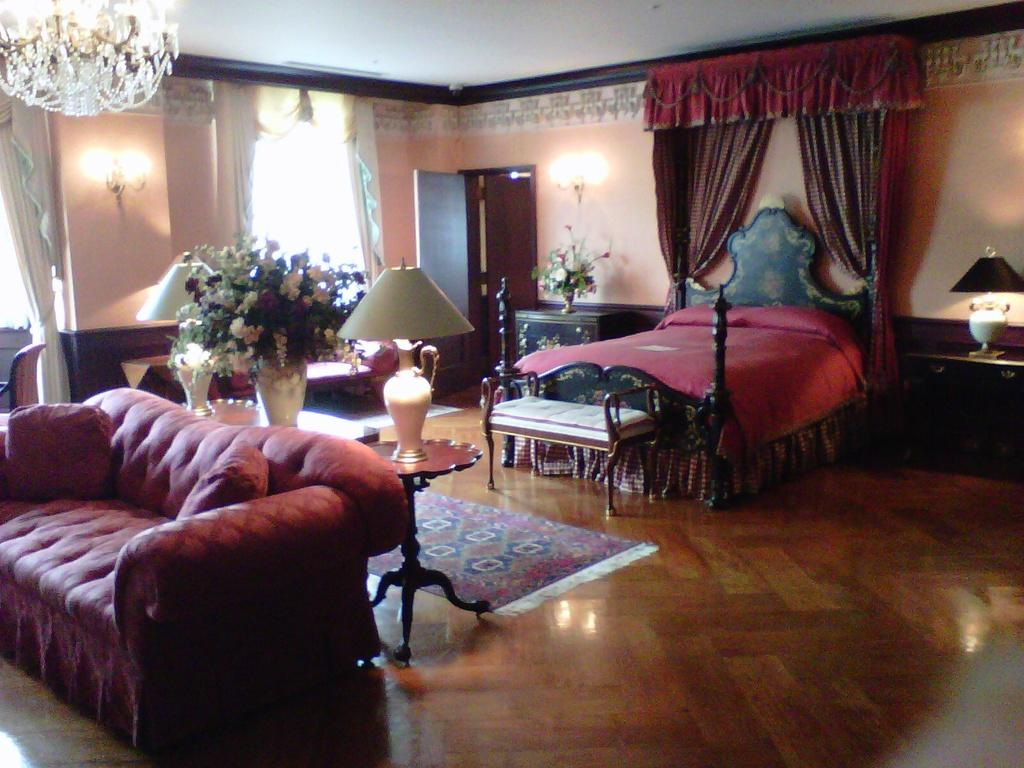What type of furniture is present in the image? There is a sofa and a bed in the image. Where is the bed located in the room? The bed is at the back of the room. What type of lighting is present in the image? There is a table lamp in the image. Where is the table lamp placed in relation to the sofa and bed? The table lamp is between the sofa and the bed. What can be found on the floor in the image? There is a door mat on the floor in the image. What type of oatmeal is being served on the bed in the image? There is no oatmeal present in the image; it features a sofa, a bed, a table lamp, and a door mat. How many times does the person in the image sneeze? There is no person present in the image, so it is impossible to determine how many times they sneeze. 